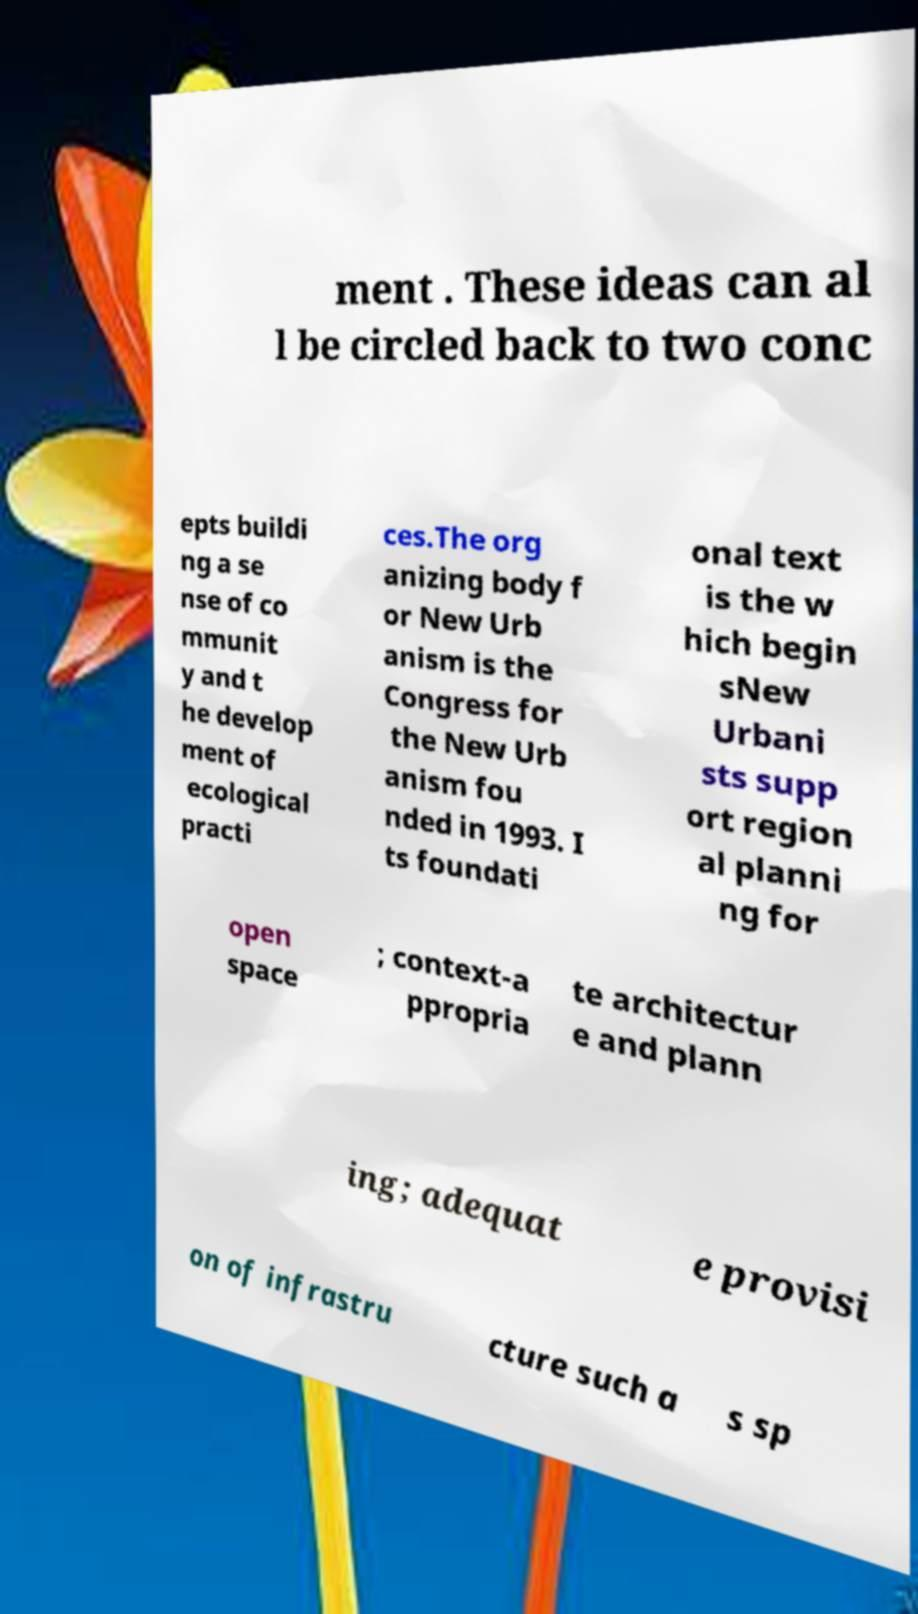I need the written content from this picture converted into text. Can you do that? ment . These ideas can al l be circled back to two conc epts buildi ng a se nse of co mmunit y and t he develop ment of ecological practi ces.The org anizing body f or New Urb anism is the Congress for the New Urb anism fou nded in 1993. I ts foundati onal text is the w hich begin sNew Urbani sts supp ort region al planni ng for open space ; context-a ppropria te architectur e and plann ing; adequat e provisi on of infrastru cture such a s sp 